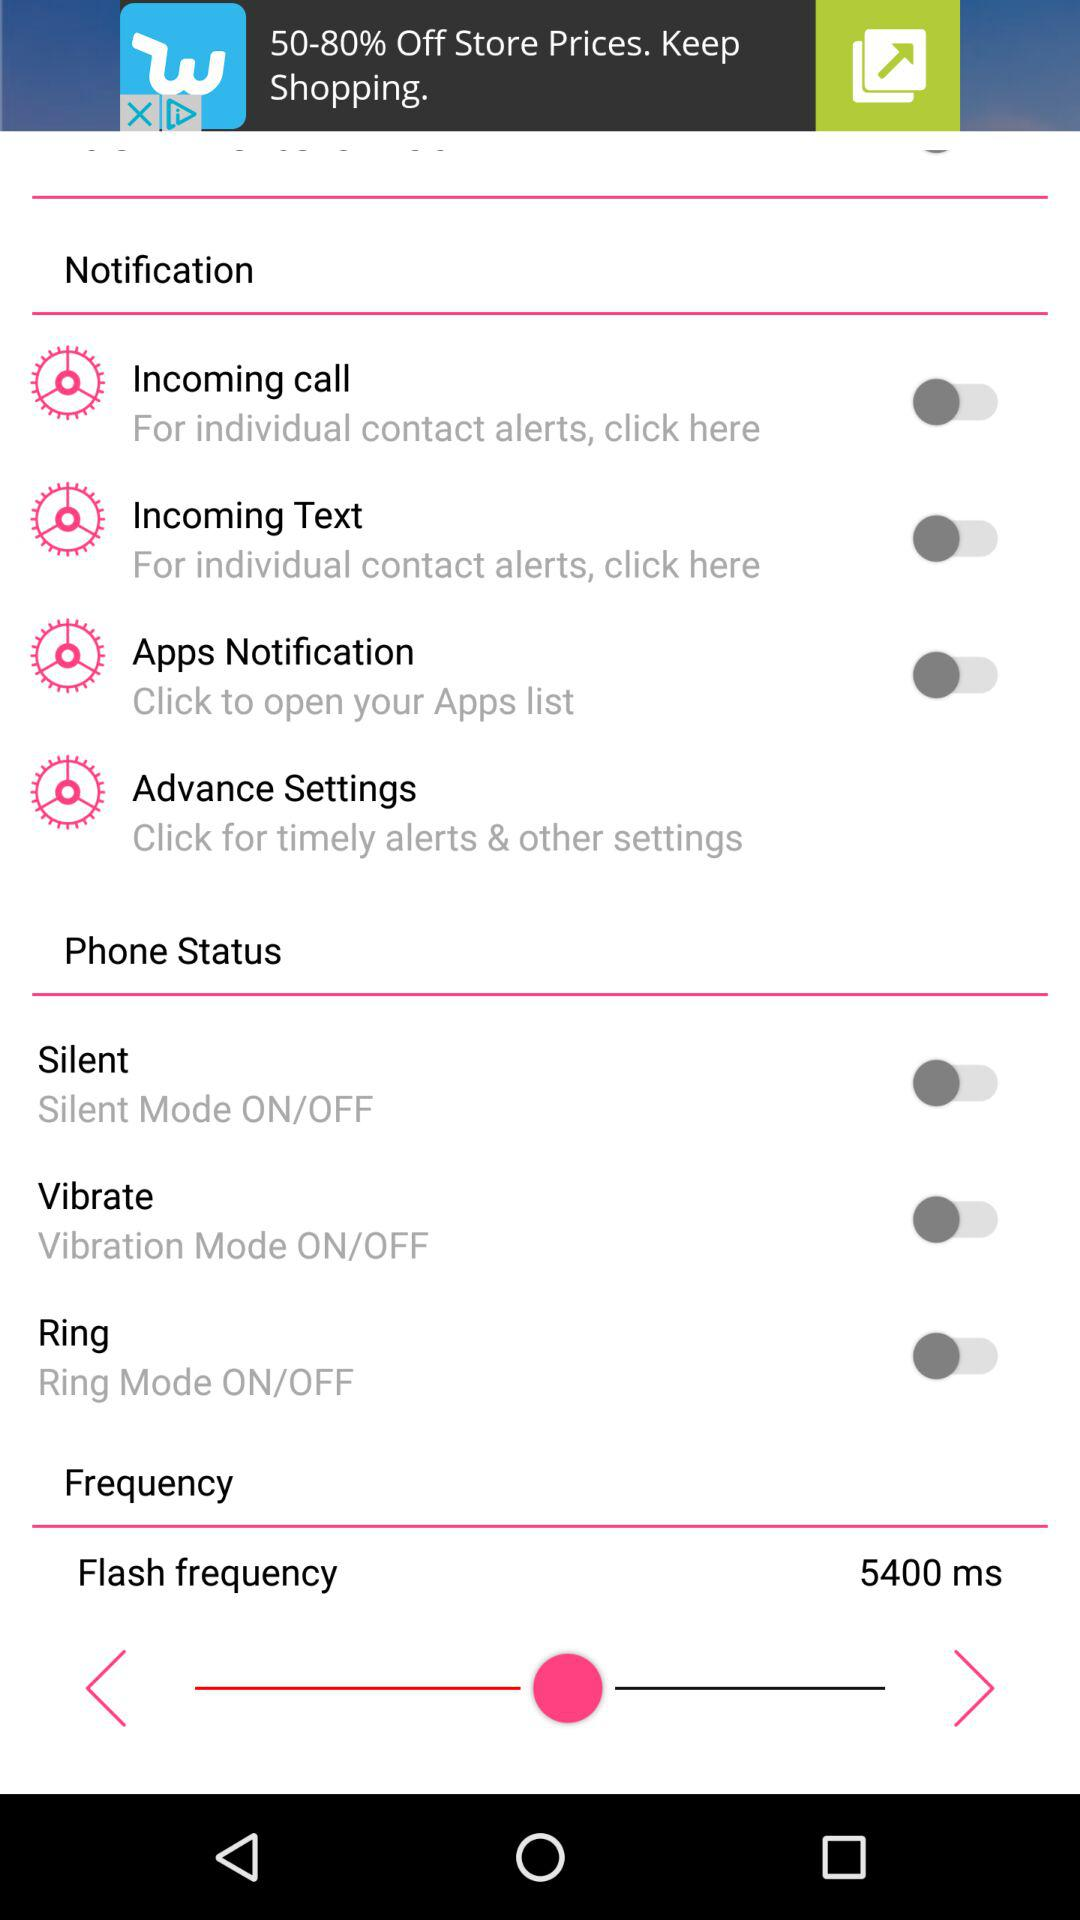What is the flash frequency? The flash frequency is 5400 ms. 